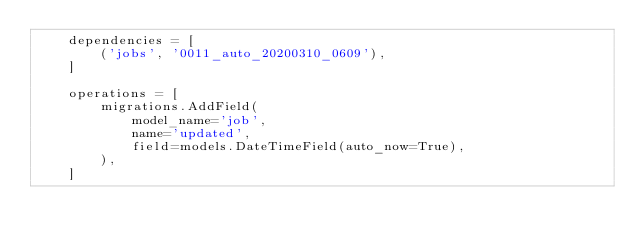<code> <loc_0><loc_0><loc_500><loc_500><_Python_>    dependencies = [
        ('jobs', '0011_auto_20200310_0609'),
    ]

    operations = [
        migrations.AddField(
            model_name='job',
            name='updated',
            field=models.DateTimeField(auto_now=True),
        ),
    ]
</code> 